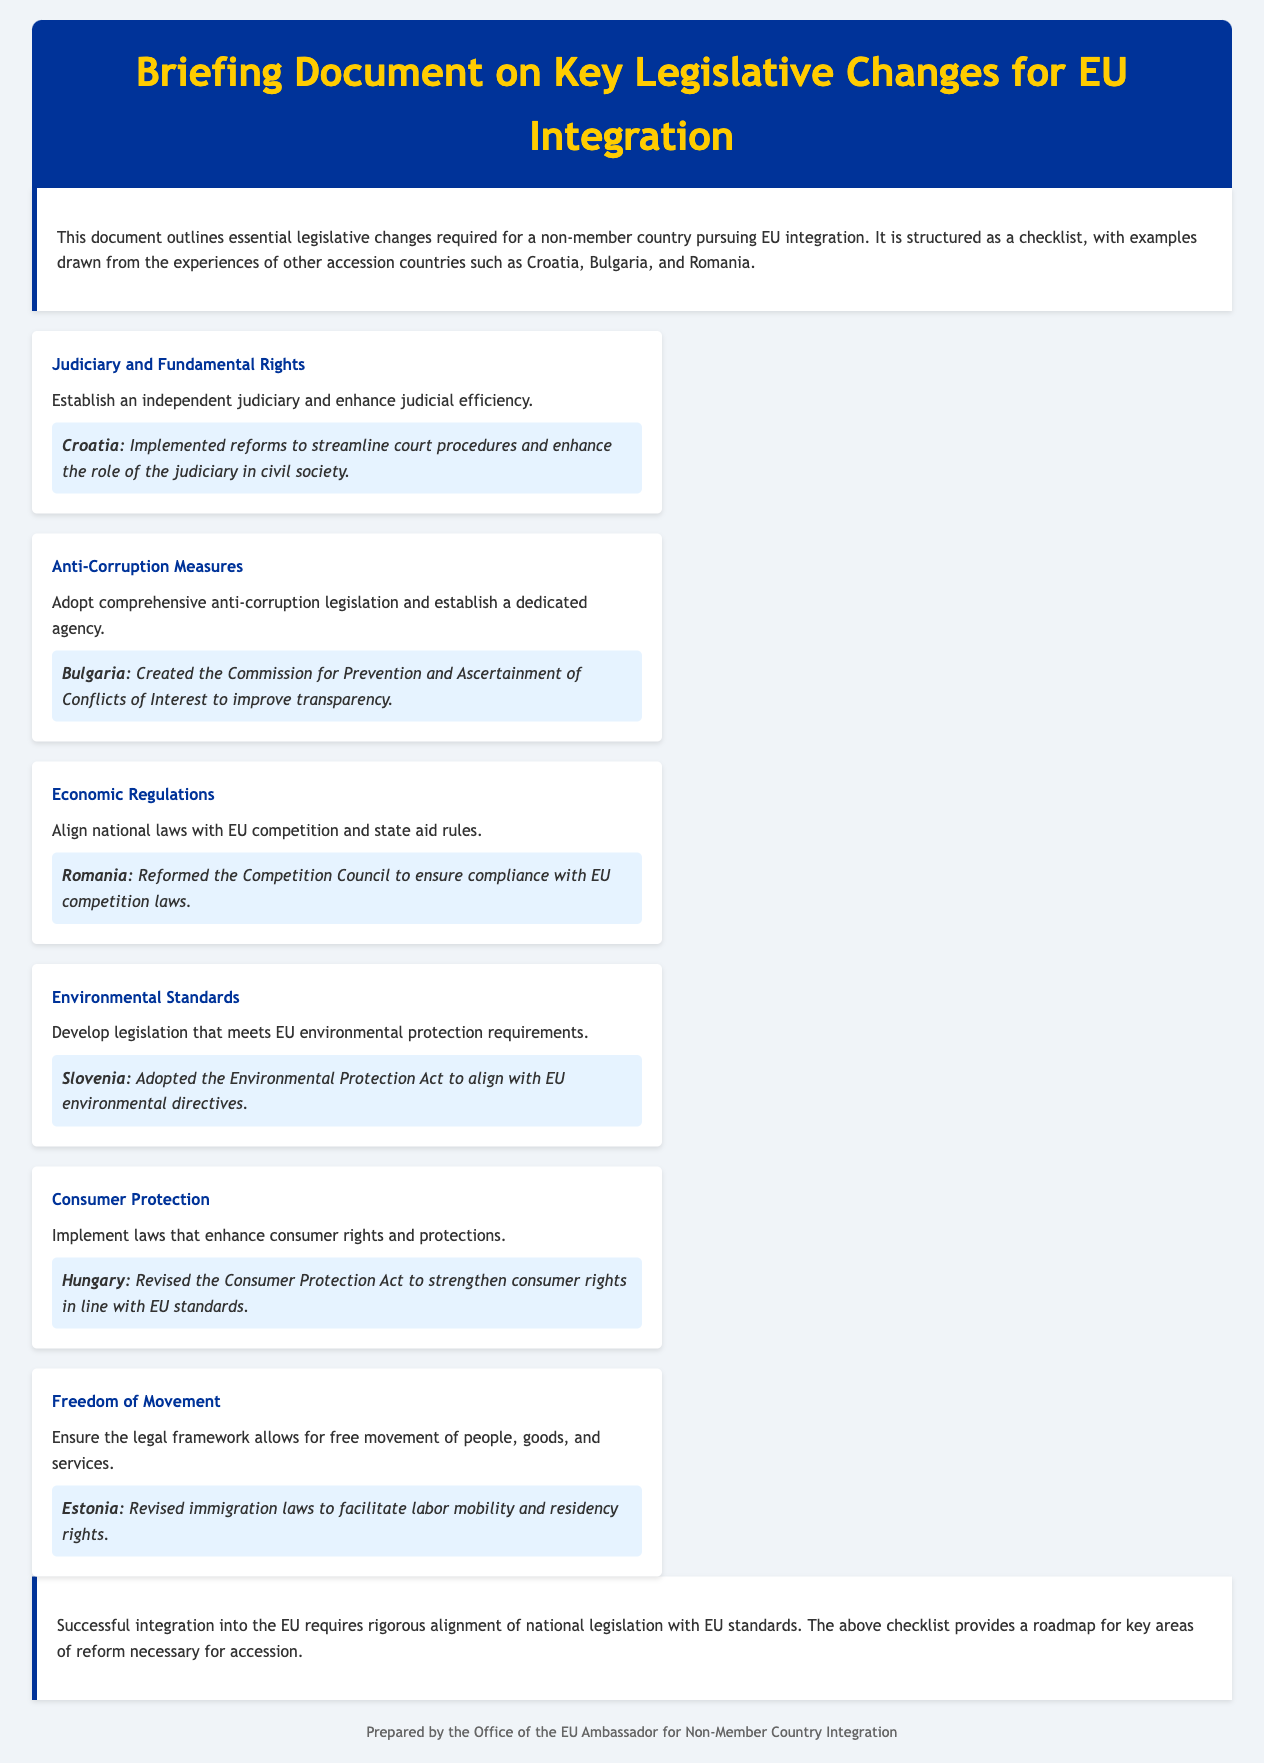What is the main purpose of this document? The document outlines essential legislative changes required for a non-member country pursuing EU integration.
Answer: Essential legislative changes for EU integration Which country implemented reforms to streamline court procedures? The document states that Croatia implemented reforms to enhance the role of the judiciary in civil society.
Answer: Croatia What agency did Bulgaria create for transparency? The document mentions the Commission for Prevention and Ascertainment of Conflicts of Interest established by Bulgaria.
Answer: Commission for Prevention and Ascertainment of Conflicts of Interest What must be aligned with EU competition rules according to the document? The document indicates that national laws must align with EU competition and state aid rules.
Answer: National laws Which environmental legislation did Slovenia adopt? Slovenia adopted the Environmental Protection Act to align with EU directives.
Answer: Environmental Protection Act What right is emphasized under "Freedom of Movement"? The legal framework must allow for free movement of people, goods, and services.
Answer: Free movement How many key areas of reform are mentioned in the document? The document lists six areas of reform necessary for accession.
Answer: Six 